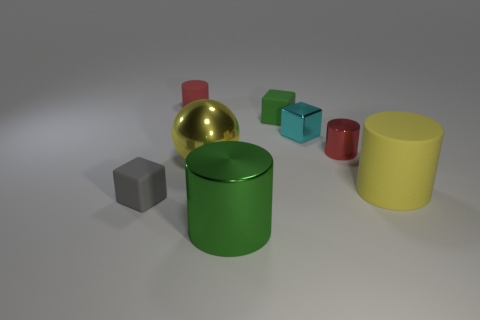Subtract all green cylinders. How many cylinders are left? 3 Subtract 1 cylinders. How many cylinders are left? 3 Subtract all blue cylinders. Subtract all red cubes. How many cylinders are left? 4 Add 2 cyan shiny objects. How many objects exist? 10 Subtract all spheres. How many objects are left? 7 Add 4 cylinders. How many cylinders are left? 8 Add 2 big brown metallic spheres. How many big brown metallic spheres exist? 2 Subtract 0 cyan spheres. How many objects are left? 8 Subtract all large yellow shiny objects. Subtract all big things. How many objects are left? 4 